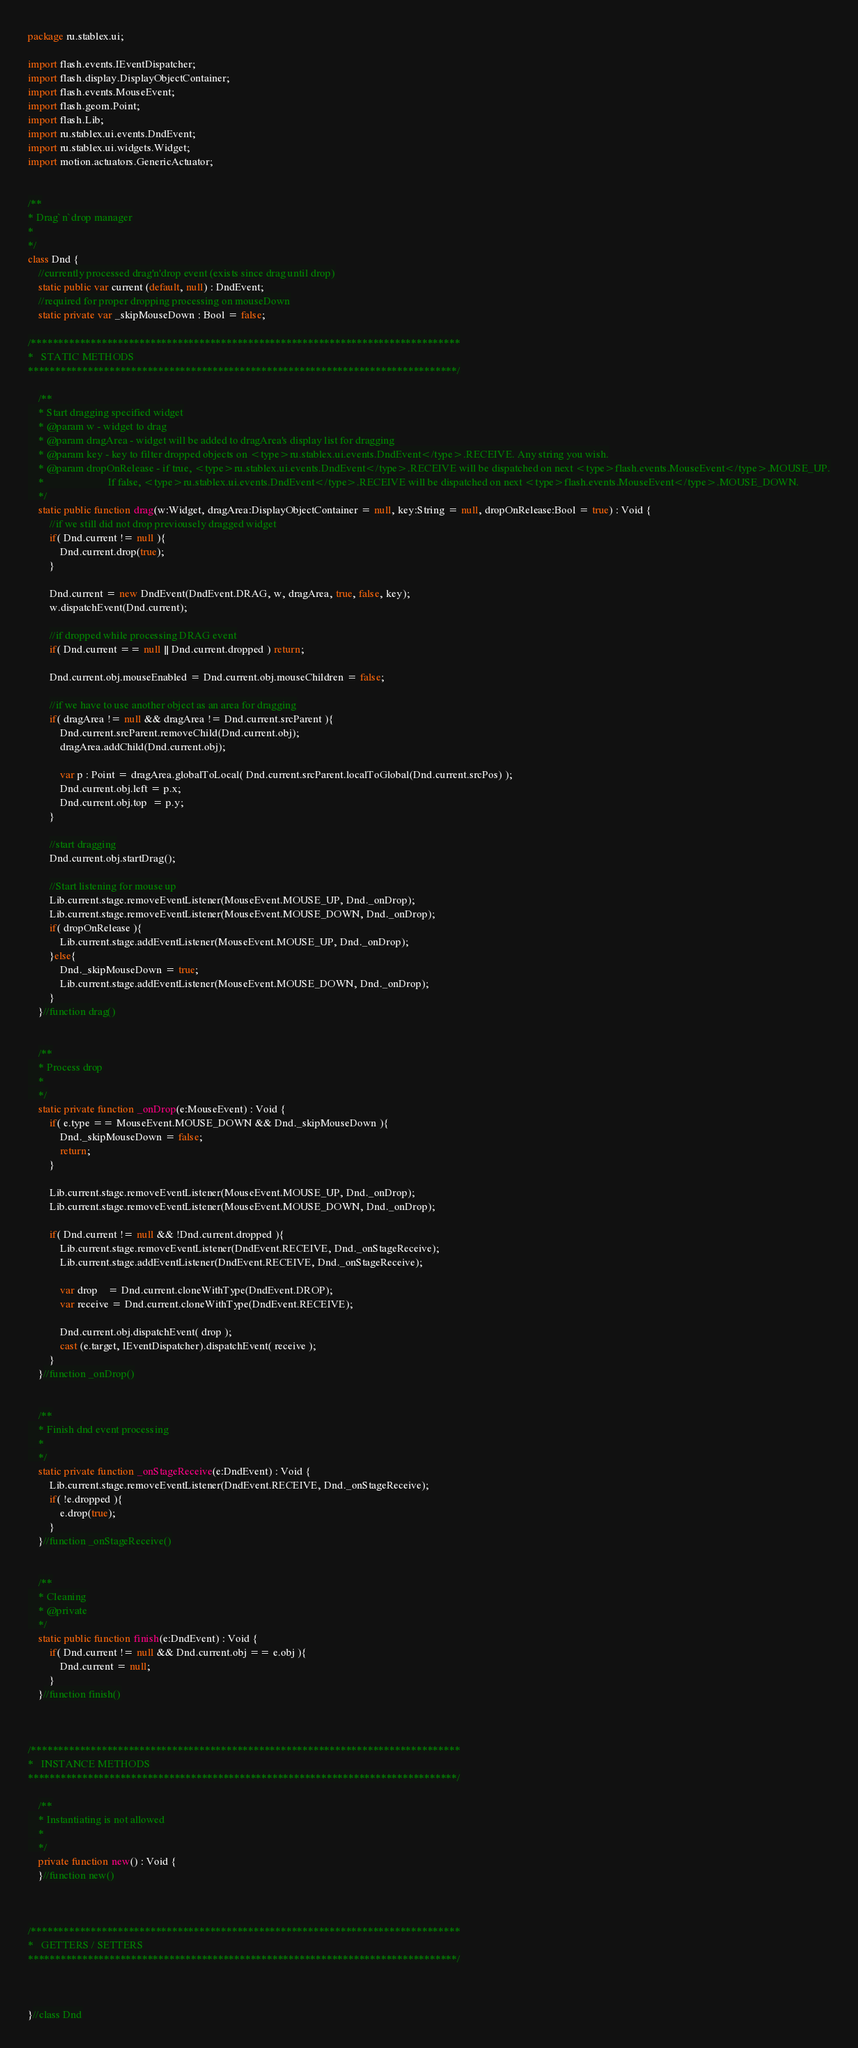Convert code to text. <code><loc_0><loc_0><loc_500><loc_500><_Haxe_>package ru.stablex.ui;

import flash.events.IEventDispatcher;
import flash.display.DisplayObjectContainer;
import flash.events.MouseEvent;
import flash.geom.Point;
import flash.Lib;
import ru.stablex.ui.events.DndEvent;
import ru.stablex.ui.widgets.Widget;
import motion.actuators.GenericActuator;


/**
* Drag`n`drop manager
*
*/
class Dnd {
    //currently processed drag'n'drop event (exists since drag until drop)
    static public var current (default, null) : DndEvent;
    //required for proper dropping processing on mouseDown
    static private var _skipMouseDown : Bool = false;

/*******************************************************************************
*   STATIC METHODS
*******************************************************************************/

    /**
    * Start dragging specified widget
    * @param w - widget to drag
    * @param dragArea - widget will be added to dragArea's display list for dragging
    * @param key - key to filter dropped objects on <type>ru.stablex.ui.events.DndEvent</type>.RECEIVE. Any string you wish.
    * @param dropOnRelease - if true, <type>ru.stablex.ui.events.DndEvent</type>.RECEIVE will be dispatched on next <type>flash.events.MouseEvent</type>.MOUSE_UP.
    *                        If false, <type>ru.stablex.ui.events.DndEvent</type>.RECEIVE will be dispatched on next <type>flash.events.MouseEvent</type>.MOUSE_DOWN.
    */
    static public function drag(w:Widget, dragArea:DisplayObjectContainer = null, key:String = null, dropOnRelease:Bool = true) : Void {
        //if we still did not drop previousely dragged widget
        if( Dnd.current != null ){
            Dnd.current.drop(true);
        }

        Dnd.current = new DndEvent(DndEvent.DRAG, w, dragArea, true, false, key);
        w.dispatchEvent(Dnd.current);

        //if dropped while processing DRAG event
        if( Dnd.current == null || Dnd.current.dropped ) return;

        Dnd.current.obj.mouseEnabled = Dnd.current.obj.mouseChildren = false;

        //if we have to use another object as an area for dragging
        if( dragArea != null && dragArea != Dnd.current.srcParent ){
            Dnd.current.srcParent.removeChild(Dnd.current.obj);
            dragArea.addChild(Dnd.current.obj);

            var p : Point = dragArea.globalToLocal( Dnd.current.srcParent.localToGlobal(Dnd.current.srcPos) );
            Dnd.current.obj.left = p.x;
            Dnd.current.obj.top  = p.y;
        }

        //start dragging
        Dnd.current.obj.startDrag();

        //Start listening for mouse up
        Lib.current.stage.removeEventListener(MouseEvent.MOUSE_UP, Dnd._onDrop);
        Lib.current.stage.removeEventListener(MouseEvent.MOUSE_DOWN, Dnd._onDrop);
        if( dropOnRelease ){
            Lib.current.stage.addEventListener(MouseEvent.MOUSE_UP, Dnd._onDrop);
        }else{
            Dnd._skipMouseDown = true;
            Lib.current.stage.addEventListener(MouseEvent.MOUSE_DOWN, Dnd._onDrop);
        }
    }//function drag()


    /**
    * Process drop
    *
    */
    static private function _onDrop(e:MouseEvent) : Void {
        if( e.type == MouseEvent.MOUSE_DOWN && Dnd._skipMouseDown ){
            Dnd._skipMouseDown = false;
            return;
        }

        Lib.current.stage.removeEventListener(MouseEvent.MOUSE_UP, Dnd._onDrop);
        Lib.current.stage.removeEventListener(MouseEvent.MOUSE_DOWN, Dnd._onDrop);

        if( Dnd.current != null && !Dnd.current.dropped ){
            Lib.current.stage.removeEventListener(DndEvent.RECEIVE, Dnd._onStageReceive);
            Lib.current.stage.addEventListener(DndEvent.RECEIVE, Dnd._onStageReceive);

            var drop    = Dnd.current.cloneWithType(DndEvent.DROP);
            var receive = Dnd.current.cloneWithType(DndEvent.RECEIVE);

            Dnd.current.obj.dispatchEvent( drop );
            cast (e.target, IEventDispatcher).dispatchEvent( receive );
        }
    }//function _onDrop()


    /**
    * Finish dnd event processing
    *
    */
    static private function _onStageReceive(e:DndEvent) : Void {
        Lib.current.stage.removeEventListener(DndEvent.RECEIVE, Dnd._onStageReceive);
        if( !e.dropped ){
            e.drop(true);
        }
    }//function _onStageReceive()


    /**
    * Cleaning
    * @private
    */
    static public function finish(e:DndEvent) : Void {
        if( Dnd.current != null && Dnd.current.obj == e.obj ){
            Dnd.current = null;
        }
    }//function finish()



/*******************************************************************************
*   INSTANCE METHODS
*******************************************************************************/

    /**
    * Instantiating is not allowed
    *
    */
    private function new() : Void {
    }//function new()



/*******************************************************************************
*   GETTERS / SETTERS
*******************************************************************************/



}//class Dnd</code> 